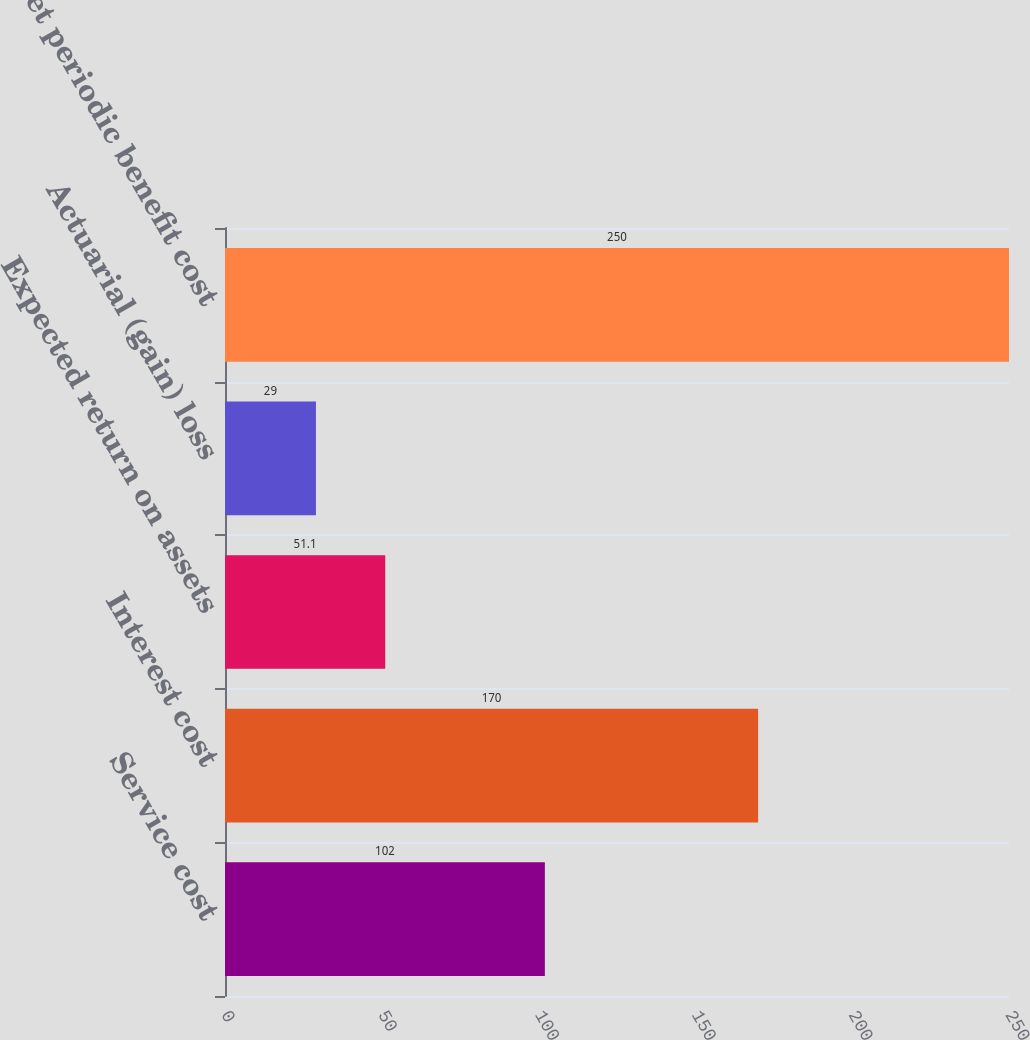Convert chart to OTSL. <chart><loc_0><loc_0><loc_500><loc_500><bar_chart><fcel>Service cost<fcel>Interest cost<fcel>Expected return on assets<fcel>Actuarial (gain) loss<fcel>Net periodic benefit cost<nl><fcel>102<fcel>170<fcel>51.1<fcel>29<fcel>250<nl></chart> 